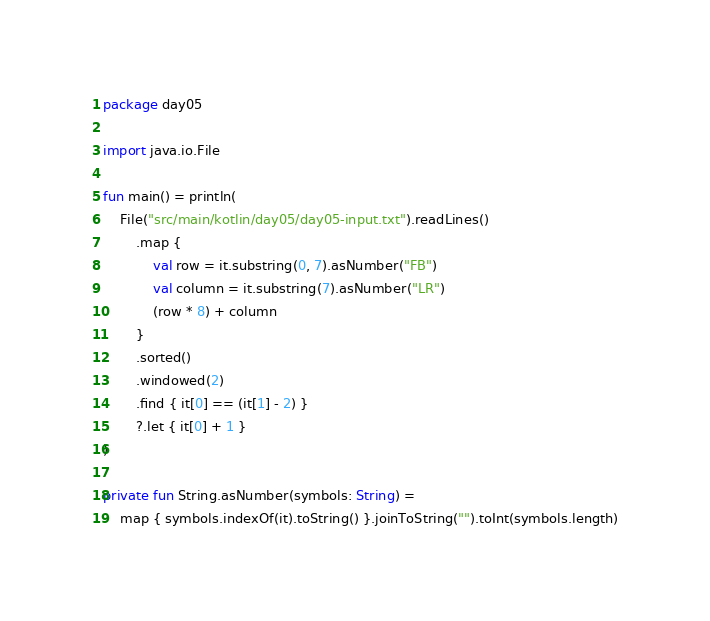<code> <loc_0><loc_0><loc_500><loc_500><_Kotlin_>package day05

import java.io.File

fun main() = println(
    File("src/main/kotlin/day05/day05-input.txt").readLines()
        .map {
            val row = it.substring(0, 7).asNumber("FB")
            val column = it.substring(7).asNumber("LR")
            (row * 8) + column
        }
        .sorted()
        .windowed(2)
        .find { it[0] == (it[1] - 2) }
        ?.let { it[0] + 1 }
)

private fun String.asNumber(symbols: String) =
    map { symbols.indexOf(it).toString() }.joinToString("").toInt(symbols.length)
</code> 